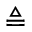Convert formula to latex. <formula><loc_0><loc_0><loc_500><loc_500>\triangle q</formula> 